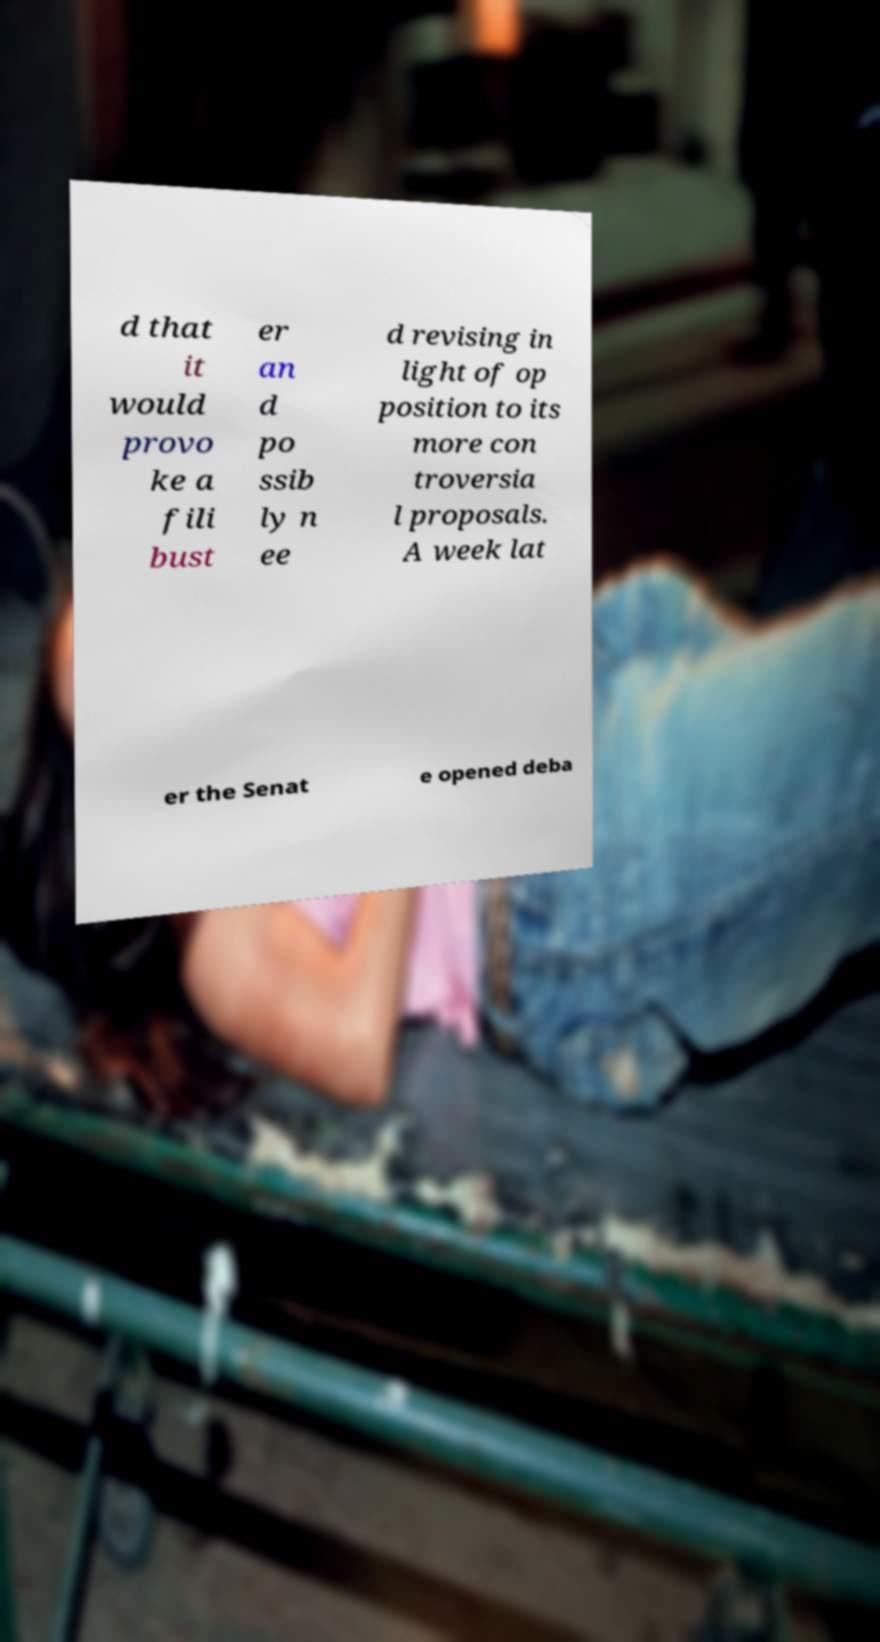For documentation purposes, I need the text within this image transcribed. Could you provide that? d that it would provo ke a fili bust er an d po ssib ly n ee d revising in light of op position to its more con troversia l proposals. A week lat er the Senat e opened deba 